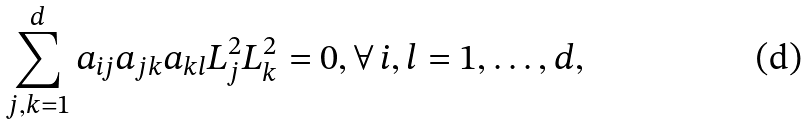<formula> <loc_0><loc_0><loc_500><loc_500>\sum _ { j , k = 1 } ^ { d } a _ { i j } a _ { j k } a _ { k l } L _ { j } ^ { 2 } L _ { k } ^ { 2 } = 0 , \forall \, i , l = 1 , \dots , d ,</formula> 